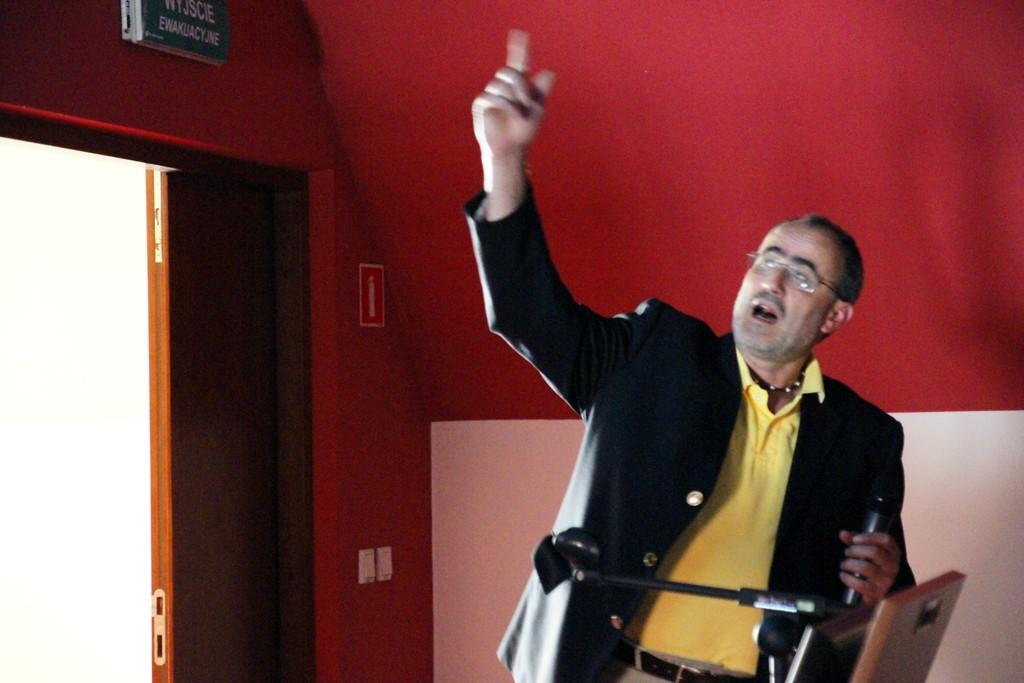What is the person in the image doing? The person is holding a microphone. What might the person be using the microphone for? The person might be using the microphone for speaking or presenting. What is near the person in the image? The person is near a podium. What can be seen on the wall in the image? There are sign boards attached to the wall. What architectural feature is present in the image? There is a door in the image. What type of debt is being discussed on the sign boards in the image? There is no mention of debt on the sign boards in the image; they are simply attached to the wall. 